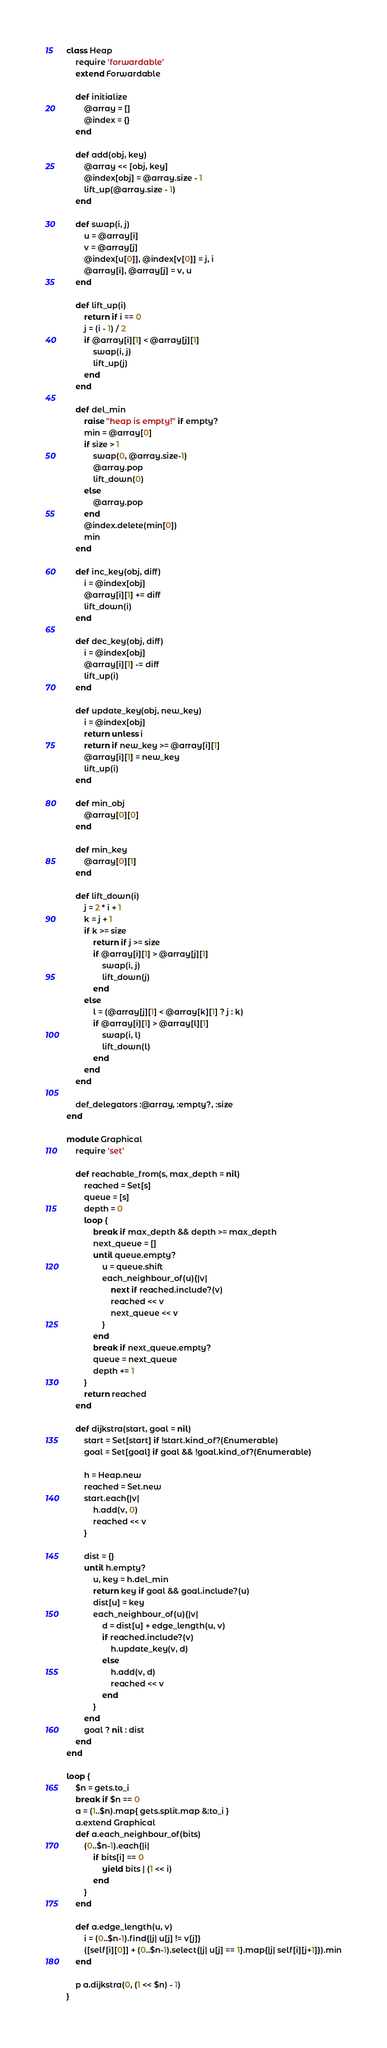<code> <loc_0><loc_0><loc_500><loc_500><_Ruby_>class Heap
	require 'forwardable'
	extend Forwardable

	def initialize
		@array = []
		@index = {}
	end

	def add(obj, key)
		@array << [obj, key]
		@index[obj] = @array.size - 1
		lift_up(@array.size - 1)
	end

	def swap(i, j)
		u = @array[i]
		v = @array[j]
		@index[u[0]], @index[v[0]] = j, i
		@array[i], @array[j] = v, u
	end

	def lift_up(i)
		return if i == 0
		j = (i - 1) / 2
		if @array[i][1] < @array[j][1]
			swap(i, j)
			lift_up(j)
		end
	end

	def del_min
		raise "heap is empty!" if empty?
		min = @array[0]
		if size > 1
			swap(0, @array.size-1)
			@array.pop
			lift_down(0)
		else
			@array.pop
		end
		@index.delete(min[0])
		min
	end

	def inc_key(obj, diff)
		i = @index[obj]
		@array[i][1] += diff
		lift_down(i)
	end

	def dec_key(obj, diff)
		i = @index[obj]
		@array[i][1] -= diff
		lift_up(i)
	end

	def update_key(obj, new_key)
		i = @index[obj]
		return unless i
		return if new_key >= @array[i][1]
		@array[i][1] = new_key
		lift_up(i)
	end

	def min_obj
		@array[0][0]
	end

	def min_key
		@array[0][1]
	end

	def lift_down(i)
		j = 2 * i + 1
		k = j + 1
		if k >= size
			return if j >= size
			if @array[i][1] > @array[j][1]
				swap(i, j)
				lift_down(j)
			end
		else
			l = (@array[j][1] < @array[k][1] ? j : k)
			if @array[i][1] > @array[l][1]
				swap(i, l)
				lift_down(l)
			end
		end
	end

	def_delegators :@array, :empty?, :size
end

module Graphical
	require 'set'

	def reachable_from(s, max_depth = nil)
		reached = Set[s]
		queue = [s]
		depth = 0
		loop {
			break if max_depth && depth >= max_depth
			next_queue = []
			until queue.empty?
				u = queue.shift
				each_neighbour_of(u){|v|
					next if reached.include?(v)
					reached << v
					next_queue << v
				}
			end
			break if next_queue.empty?
			queue = next_queue
			depth += 1
		}
		return reached
	end

	def dijkstra(start, goal = nil)
		start = Set[start] if !start.kind_of?(Enumerable)
		goal = Set[goal] if goal && !goal.kind_of?(Enumerable)

		h = Heap.new
		reached = Set.new
		start.each{|v|
			h.add(v, 0)
			reached << v
		}

		dist = {}
		until h.empty?
			u, key = h.del_min
			return key if goal && goal.include?(u)
			dist[u] = key
			each_neighbour_of(u){|v|
				d = dist[u] + edge_length(u, v)
				if reached.include?(v)
					h.update_key(v, d)
				else
					h.add(v, d)
					reached << v
				end
			}
		end
		goal ? nil : dist
	end
end

loop {
	$n = gets.to_i
	break if $n == 0
	a = (1..$n).map{ gets.split.map &:to_i }
	a.extend Graphical
	def a.each_neighbour_of(bits)
		(0..$n-1).each{|i|
			if bits[i] == 0
				yield bits | (1 << i)
			end
		}
	end

	def a.edge_length(u, v)
		i = (0..$n-1).find{|j| u[j] != v[j]}
		([self[i][0]] + (0..$n-1).select{|j| u[j] == 1}.map{|j| self[i][j+1]}).min
	end

	p a.dijkstra(0, (1 << $n) - 1)
}</code> 